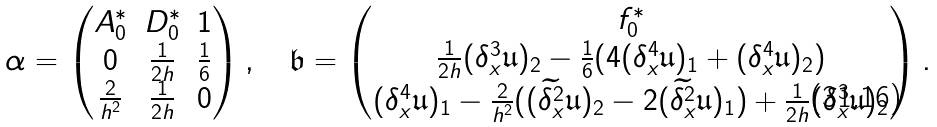Convert formula to latex. <formula><loc_0><loc_0><loc_500><loc_500>\alpha = \begin{pmatrix} A _ { 0 } ^ { \ast } & D _ { 0 } ^ { \ast } & 1 \\ 0 & \frac { 1 } { 2 h } & \frac { 1 } { 6 } \\ \frac { 2 } { h ^ { 2 } } & \frac { 1 } { 2 h } & 0 \end{pmatrix} , \quad \mathfrak { b } = \begin{pmatrix} f _ { 0 } ^ { \ast } \\ \frac { 1 } { 2 h } ( \delta _ { x } ^ { 3 } \mathfrak { u } ) _ { 2 } - \frac { 1 } { 6 } ( 4 ( \delta _ { x } ^ { 4 } \mathfrak { u } ) _ { 1 } + ( \delta _ { x } ^ { 4 } \mathfrak { u } ) _ { 2 } ) \\ ( \delta _ { x } ^ { 4 } \mathfrak { u } ) _ { 1 } - \frac { 2 } { h ^ { 2 } } ( ( \widetilde { \delta _ { x } ^ { 2 } } \mathfrak { u } ) _ { 2 } - 2 ( \widetilde { \delta _ { x } ^ { 2 } } \mathfrak { u } ) _ { 1 } ) + \frac { 1 } { 2 h } ( \delta _ { x } ^ { 3 } \mathfrak { u } ) _ { 2 } \end{pmatrix} .</formula> 